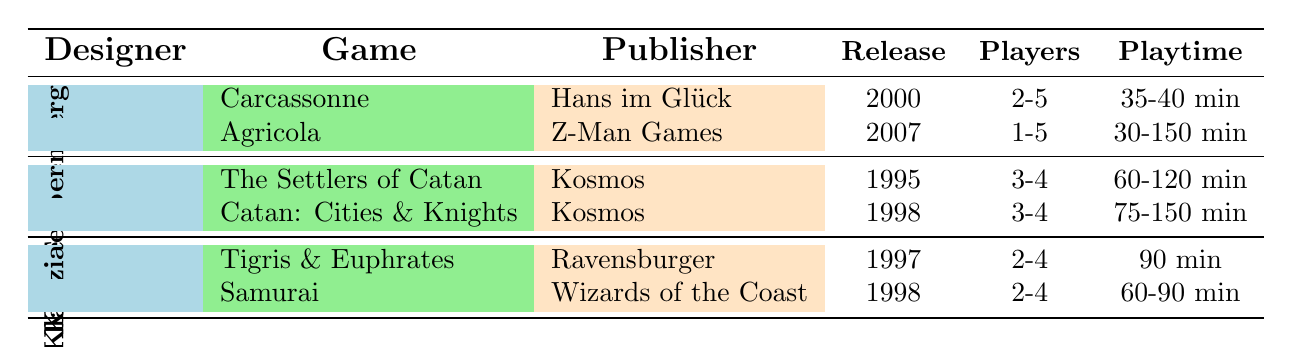What is the release year of Agricola? The table lists Agricola under the designer Uwe Rosenberg. By locating the row for Agricola, we see its Release date column shows "2007".
Answer: 2007 Who published The Settlers of Catan? The table shows The Settlers of Catan under Klaus Teuber. The Publisher column for this game indicates "Kosmos".
Answer: Kosmos Which game has the longest playtime range? By examining the Playtime column, we see that Agricola has a range from 30 to 150 minutes, which is broader than any other game's playtime listed in the table. Therefore, it has the longest playtime range.
Answer: Agricola How many players can play Samurai? The table indicates that Samurai, designed by Reiner Knizia, accommodates "2-4" players as listed in the Players column.
Answer: 2-4 Is Carcassonne released before or after 2000? The Release date for Carcassonne is listed as "2000", which means it was released in the year 2000, making it not before that year but exactly in it.
Answer: No What is the average number of players across all games listed? The Players column shows the ranges as follows: Carcassonne (2-5), Agricola (1-5), The Settlers of Catan (3-4), Catan: Cities & Knights (3-4), Tigris & Euphrates (2-4), Samurai (2-4). These can be interpreted as averages: (3.5 + 3 + 3.5 + 3.5 + 3 + 3) / 6 = 3.42 (rounded) using midpoint values. The average number of players across these games is approximately 3.42.
Answer: 3.42 Which designer has the most games listed in the table? Uwe Rosenberg has 2 games listed (Carcassonne and Agricola), Klaus Teuber has 2 games (The Settlers of Catan and Catan: Cities & Knights), and Reiner Knizia has 2 games (Tigris & Euphrates and Samurai). Therefore, all designers have the same number of games listed, which is 2.
Answer: None Is Samurai published by Ravensburger? The table states that Samurai is published by "Wizards of the Coast", which indicates that the statement is false.
Answer: No What percentage of the games has a playtime of less than 90 minutes? From the games listed, only Carcassonne (35-40 min), Agricola (30-150 min), and Samurai (60-90 min) have playtimes under 90 minutes. There are 6 total games, so (3/6) * 100 = 50%.
Answer: 50% 